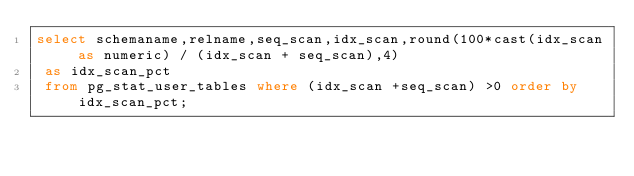Convert code to text. <code><loc_0><loc_0><loc_500><loc_500><_SQL_>select schemaname,relname,seq_scan,idx_scan,round(100*cast(idx_scan as numeric) / (idx_scan + seq_scan),4)
 as idx_scan_pct 
 from pg_stat_user_tables where (idx_scan +seq_scan) >0 order by idx_scan_pct;</code> 